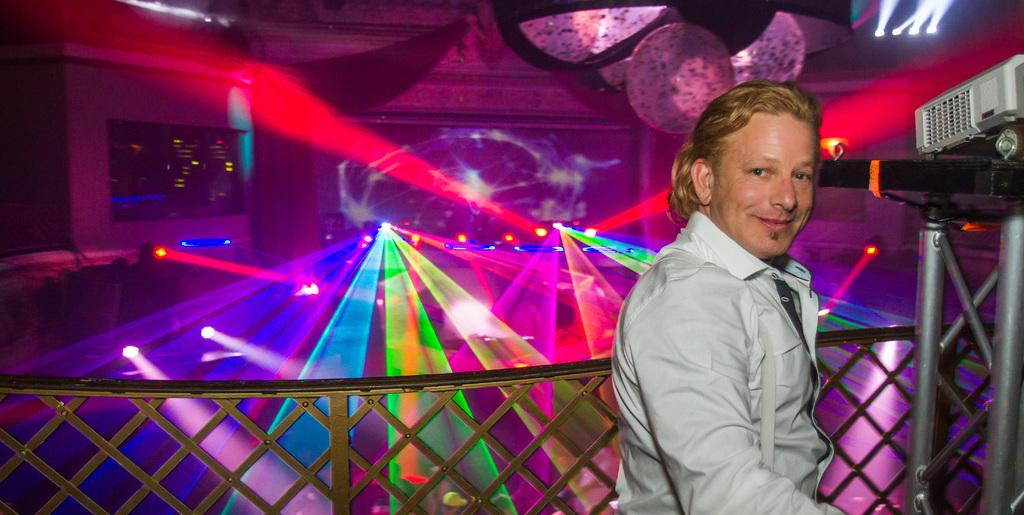What is present in the image? There is a person in the image. What is near the person? There is a railing near the person. What can be seen on the right side of the image? There is a stand on the right side of the image. What is on the stand? Something is on the stand. What can be seen in the background of the image? There are lights visible in the background of the image. What type of drum is the person playing in the image? There is no drum present in the image. Is the person in the image accompanied by a crook? There is no crook present in the image. 